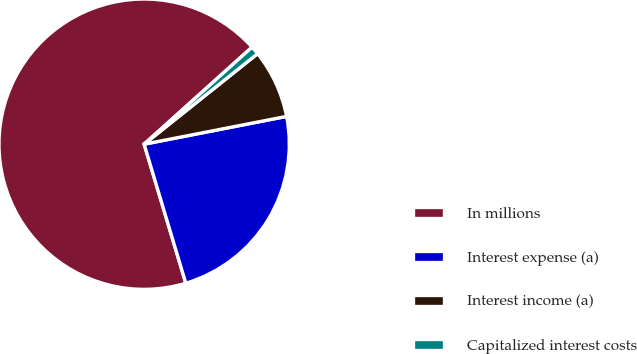Convert chart to OTSL. <chart><loc_0><loc_0><loc_500><loc_500><pie_chart><fcel>In millions<fcel>Interest expense (a)<fcel>Interest income (a)<fcel>Capitalized interest costs<nl><fcel>67.97%<fcel>23.43%<fcel>7.65%<fcel>0.94%<nl></chart> 